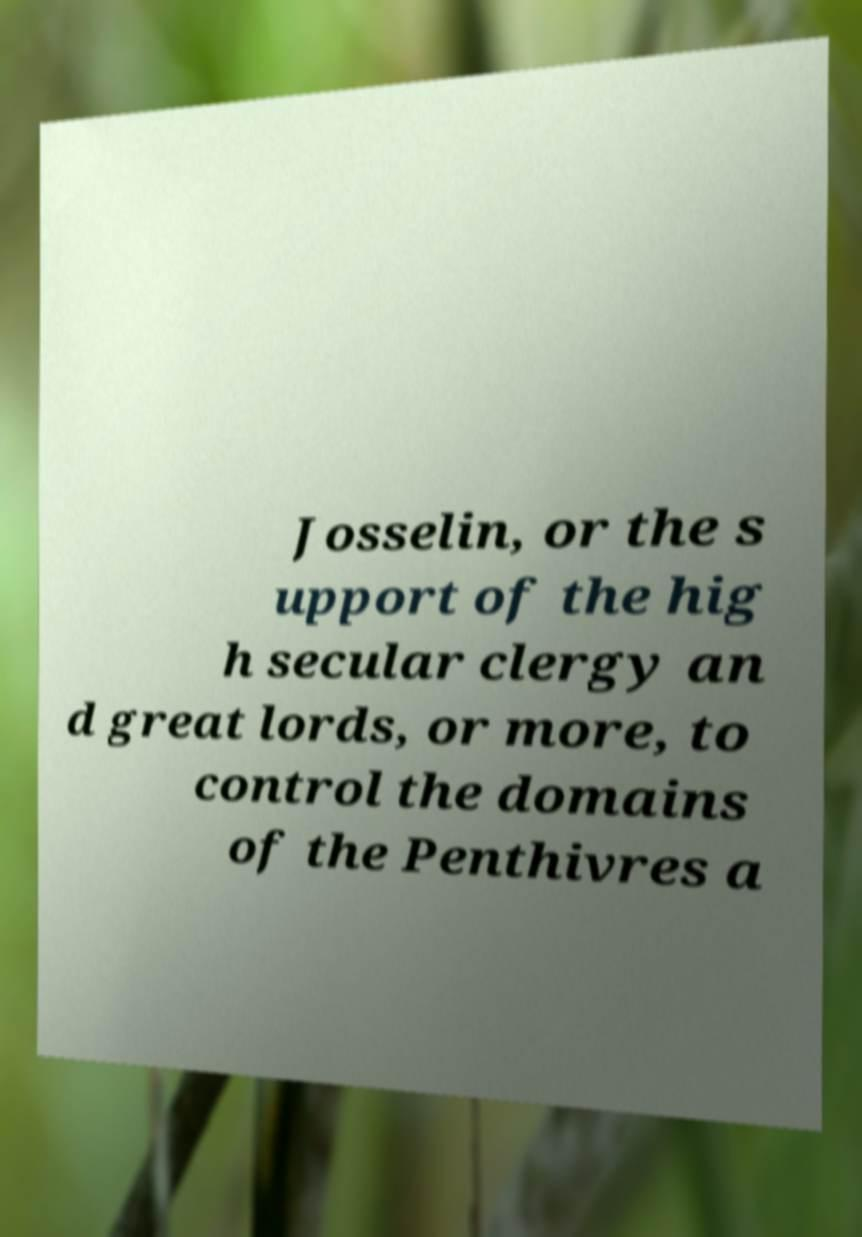I need the written content from this picture converted into text. Can you do that? Josselin, or the s upport of the hig h secular clergy an d great lords, or more, to control the domains of the Penthivres a 